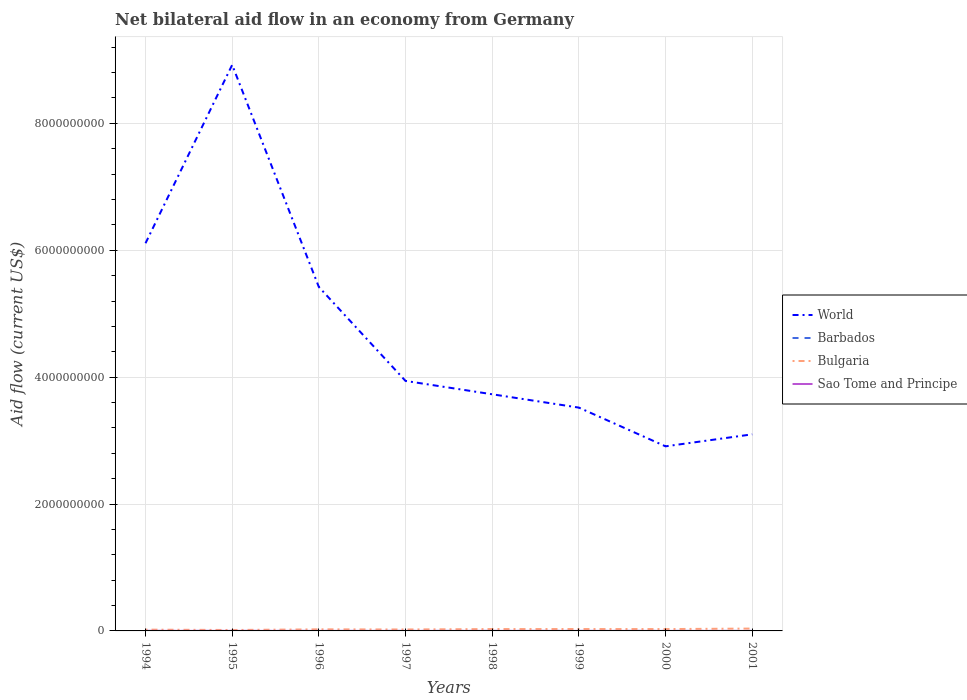How many different coloured lines are there?
Make the answer very short. 4. Is the number of lines equal to the number of legend labels?
Ensure brevity in your answer.  Yes. What is the total net bilateral aid flow in Bulgaria in the graph?
Your response must be concise. -1.44e+07. What is the difference between the highest and the second highest net bilateral aid flow in Sao Tome and Principe?
Ensure brevity in your answer.  8.80e+05. What is the difference between the highest and the lowest net bilateral aid flow in World?
Make the answer very short. 3. Is the net bilateral aid flow in Sao Tome and Principe strictly greater than the net bilateral aid flow in Barbados over the years?
Offer a terse response. No. What is the difference between two consecutive major ticks on the Y-axis?
Your response must be concise. 2.00e+09. Are the values on the major ticks of Y-axis written in scientific E-notation?
Make the answer very short. No. How many legend labels are there?
Offer a very short reply. 4. How are the legend labels stacked?
Offer a very short reply. Vertical. What is the title of the graph?
Make the answer very short. Net bilateral aid flow in an economy from Germany. Does "China" appear as one of the legend labels in the graph?
Your answer should be compact. No. What is the Aid flow (current US$) in World in 1994?
Your answer should be compact. 6.11e+09. What is the Aid flow (current US$) in Bulgaria in 1994?
Your answer should be compact. 2.02e+07. What is the Aid flow (current US$) of Sao Tome and Principe in 1994?
Offer a very short reply. 9.20e+05. What is the Aid flow (current US$) of World in 1995?
Keep it short and to the point. 8.92e+09. What is the Aid flow (current US$) in Barbados in 1995?
Ensure brevity in your answer.  3.00e+04. What is the Aid flow (current US$) of Bulgaria in 1995?
Give a very brief answer. 1.47e+07. What is the Aid flow (current US$) of Sao Tome and Principe in 1995?
Offer a terse response. 8.30e+05. What is the Aid flow (current US$) of World in 1996?
Your response must be concise. 5.42e+09. What is the Aid flow (current US$) of Bulgaria in 1996?
Keep it short and to the point. 2.50e+07. What is the Aid flow (current US$) in Sao Tome and Principe in 1996?
Ensure brevity in your answer.  5.80e+05. What is the Aid flow (current US$) of World in 1997?
Offer a very short reply. 3.94e+09. What is the Aid flow (current US$) in Barbados in 1997?
Offer a very short reply. 5.00e+04. What is the Aid flow (current US$) in Bulgaria in 1997?
Offer a very short reply. 2.27e+07. What is the Aid flow (current US$) of Sao Tome and Principe in 1997?
Offer a terse response. 3.00e+05. What is the Aid flow (current US$) in World in 1998?
Keep it short and to the point. 3.73e+09. What is the Aid flow (current US$) of Barbados in 1998?
Give a very brief answer. 7.00e+04. What is the Aid flow (current US$) of Bulgaria in 1998?
Ensure brevity in your answer.  2.92e+07. What is the Aid flow (current US$) in World in 1999?
Provide a succinct answer. 3.52e+09. What is the Aid flow (current US$) in Barbados in 1999?
Make the answer very short. 1.20e+05. What is the Aid flow (current US$) in Bulgaria in 1999?
Provide a short and direct response. 2.96e+07. What is the Aid flow (current US$) in World in 2000?
Offer a terse response. 2.91e+09. What is the Aid flow (current US$) of Barbados in 2000?
Provide a short and direct response. 4.00e+04. What is the Aid flow (current US$) of Bulgaria in 2000?
Make the answer very short. 2.91e+07. What is the Aid flow (current US$) in Sao Tome and Principe in 2000?
Keep it short and to the point. 1.60e+05. What is the Aid flow (current US$) in World in 2001?
Provide a short and direct response. 3.10e+09. What is the Aid flow (current US$) of Bulgaria in 2001?
Keep it short and to the point. 3.71e+07. Across all years, what is the maximum Aid flow (current US$) in World?
Provide a succinct answer. 8.92e+09. Across all years, what is the maximum Aid flow (current US$) of Barbados?
Give a very brief answer. 1.20e+05. Across all years, what is the maximum Aid flow (current US$) in Bulgaria?
Your answer should be compact. 3.71e+07. Across all years, what is the maximum Aid flow (current US$) of Sao Tome and Principe?
Offer a terse response. 9.20e+05. Across all years, what is the minimum Aid flow (current US$) in World?
Offer a very short reply. 2.91e+09. Across all years, what is the minimum Aid flow (current US$) in Barbados?
Offer a terse response. 3.00e+04. Across all years, what is the minimum Aid flow (current US$) of Bulgaria?
Offer a very short reply. 1.47e+07. Across all years, what is the minimum Aid flow (current US$) in Sao Tome and Principe?
Offer a terse response. 4.00e+04. What is the total Aid flow (current US$) in World in the graph?
Provide a short and direct response. 3.77e+1. What is the total Aid flow (current US$) of Barbados in the graph?
Your answer should be very brief. 4.60e+05. What is the total Aid flow (current US$) of Bulgaria in the graph?
Your answer should be compact. 2.08e+08. What is the total Aid flow (current US$) in Sao Tome and Principe in the graph?
Offer a terse response. 3.50e+06. What is the difference between the Aid flow (current US$) of World in 1994 and that in 1995?
Provide a short and direct response. -2.81e+09. What is the difference between the Aid flow (current US$) in Bulgaria in 1994 and that in 1995?
Provide a short and direct response. 5.55e+06. What is the difference between the Aid flow (current US$) of Sao Tome and Principe in 1994 and that in 1995?
Offer a terse response. 9.00e+04. What is the difference between the Aid flow (current US$) of World in 1994 and that in 1996?
Give a very brief answer. 6.89e+08. What is the difference between the Aid flow (current US$) of Barbados in 1994 and that in 1996?
Your answer should be very brief. 0. What is the difference between the Aid flow (current US$) in Bulgaria in 1994 and that in 1996?
Keep it short and to the point. -4.76e+06. What is the difference between the Aid flow (current US$) in World in 1994 and that in 1997?
Ensure brevity in your answer.  2.17e+09. What is the difference between the Aid flow (current US$) in Bulgaria in 1994 and that in 1997?
Your answer should be very brief. -2.50e+06. What is the difference between the Aid flow (current US$) in Sao Tome and Principe in 1994 and that in 1997?
Ensure brevity in your answer.  6.20e+05. What is the difference between the Aid flow (current US$) of World in 1994 and that in 1998?
Keep it short and to the point. 2.38e+09. What is the difference between the Aid flow (current US$) in Barbados in 1994 and that in 1998?
Your answer should be very brief. -4.00e+04. What is the difference between the Aid flow (current US$) in Bulgaria in 1994 and that in 1998?
Ensure brevity in your answer.  -9.01e+06. What is the difference between the Aid flow (current US$) of Sao Tome and Principe in 1994 and that in 1998?
Provide a succinct answer. 4.90e+05. What is the difference between the Aid flow (current US$) of World in 1994 and that in 1999?
Provide a succinct answer. 2.59e+09. What is the difference between the Aid flow (current US$) of Barbados in 1994 and that in 1999?
Offer a terse response. -9.00e+04. What is the difference between the Aid flow (current US$) in Bulgaria in 1994 and that in 1999?
Your answer should be very brief. -9.35e+06. What is the difference between the Aid flow (current US$) of Sao Tome and Principe in 1994 and that in 1999?
Provide a succinct answer. 6.80e+05. What is the difference between the Aid flow (current US$) of World in 1994 and that in 2000?
Your answer should be very brief. 3.20e+09. What is the difference between the Aid flow (current US$) of Barbados in 1994 and that in 2000?
Offer a very short reply. -10000. What is the difference between the Aid flow (current US$) in Bulgaria in 1994 and that in 2000?
Make the answer very short. -8.87e+06. What is the difference between the Aid flow (current US$) of Sao Tome and Principe in 1994 and that in 2000?
Your answer should be compact. 7.60e+05. What is the difference between the Aid flow (current US$) of World in 1994 and that in 2001?
Your answer should be very brief. 3.01e+09. What is the difference between the Aid flow (current US$) of Bulgaria in 1994 and that in 2001?
Ensure brevity in your answer.  -1.69e+07. What is the difference between the Aid flow (current US$) in Sao Tome and Principe in 1994 and that in 2001?
Your answer should be compact. 8.80e+05. What is the difference between the Aid flow (current US$) of World in 1995 and that in 1996?
Keep it short and to the point. 3.50e+09. What is the difference between the Aid flow (current US$) of Bulgaria in 1995 and that in 1996?
Provide a succinct answer. -1.03e+07. What is the difference between the Aid flow (current US$) of Sao Tome and Principe in 1995 and that in 1996?
Make the answer very short. 2.50e+05. What is the difference between the Aid flow (current US$) in World in 1995 and that in 1997?
Your answer should be very brief. 4.98e+09. What is the difference between the Aid flow (current US$) of Bulgaria in 1995 and that in 1997?
Keep it short and to the point. -8.05e+06. What is the difference between the Aid flow (current US$) of Sao Tome and Principe in 1995 and that in 1997?
Give a very brief answer. 5.30e+05. What is the difference between the Aid flow (current US$) in World in 1995 and that in 1998?
Your answer should be very brief. 5.19e+09. What is the difference between the Aid flow (current US$) in Barbados in 1995 and that in 1998?
Your answer should be compact. -4.00e+04. What is the difference between the Aid flow (current US$) in Bulgaria in 1995 and that in 1998?
Make the answer very short. -1.46e+07. What is the difference between the Aid flow (current US$) of World in 1995 and that in 1999?
Give a very brief answer. 5.40e+09. What is the difference between the Aid flow (current US$) in Barbados in 1995 and that in 1999?
Offer a very short reply. -9.00e+04. What is the difference between the Aid flow (current US$) in Bulgaria in 1995 and that in 1999?
Your response must be concise. -1.49e+07. What is the difference between the Aid flow (current US$) of Sao Tome and Principe in 1995 and that in 1999?
Ensure brevity in your answer.  5.90e+05. What is the difference between the Aid flow (current US$) in World in 1995 and that in 2000?
Your answer should be very brief. 6.01e+09. What is the difference between the Aid flow (current US$) of Bulgaria in 1995 and that in 2000?
Offer a very short reply. -1.44e+07. What is the difference between the Aid flow (current US$) in Sao Tome and Principe in 1995 and that in 2000?
Give a very brief answer. 6.70e+05. What is the difference between the Aid flow (current US$) in World in 1995 and that in 2001?
Your answer should be very brief. 5.82e+09. What is the difference between the Aid flow (current US$) of Bulgaria in 1995 and that in 2001?
Your answer should be compact. -2.24e+07. What is the difference between the Aid flow (current US$) in Sao Tome and Principe in 1995 and that in 2001?
Your answer should be very brief. 7.90e+05. What is the difference between the Aid flow (current US$) in World in 1996 and that in 1997?
Provide a succinct answer. 1.48e+09. What is the difference between the Aid flow (current US$) of Barbados in 1996 and that in 1997?
Your answer should be compact. -2.00e+04. What is the difference between the Aid flow (current US$) in Bulgaria in 1996 and that in 1997?
Offer a terse response. 2.26e+06. What is the difference between the Aid flow (current US$) of Sao Tome and Principe in 1996 and that in 1997?
Provide a succinct answer. 2.80e+05. What is the difference between the Aid flow (current US$) in World in 1996 and that in 1998?
Make the answer very short. 1.69e+09. What is the difference between the Aid flow (current US$) of Bulgaria in 1996 and that in 1998?
Your answer should be compact. -4.25e+06. What is the difference between the Aid flow (current US$) in World in 1996 and that in 1999?
Your response must be concise. 1.90e+09. What is the difference between the Aid flow (current US$) of Barbados in 1996 and that in 1999?
Your answer should be very brief. -9.00e+04. What is the difference between the Aid flow (current US$) of Bulgaria in 1996 and that in 1999?
Make the answer very short. -4.59e+06. What is the difference between the Aid flow (current US$) in World in 1996 and that in 2000?
Provide a succinct answer. 2.51e+09. What is the difference between the Aid flow (current US$) of Bulgaria in 1996 and that in 2000?
Provide a short and direct response. -4.11e+06. What is the difference between the Aid flow (current US$) of Sao Tome and Principe in 1996 and that in 2000?
Provide a succinct answer. 4.20e+05. What is the difference between the Aid flow (current US$) of World in 1996 and that in 2001?
Give a very brief answer. 2.32e+09. What is the difference between the Aid flow (current US$) of Barbados in 1996 and that in 2001?
Ensure brevity in your answer.  -6.00e+04. What is the difference between the Aid flow (current US$) of Bulgaria in 1996 and that in 2001?
Offer a terse response. -1.21e+07. What is the difference between the Aid flow (current US$) in Sao Tome and Principe in 1996 and that in 2001?
Make the answer very short. 5.40e+05. What is the difference between the Aid flow (current US$) of World in 1997 and that in 1998?
Your answer should be compact. 2.10e+08. What is the difference between the Aid flow (current US$) of Bulgaria in 1997 and that in 1998?
Offer a terse response. -6.51e+06. What is the difference between the Aid flow (current US$) of Sao Tome and Principe in 1997 and that in 1998?
Provide a succinct answer. -1.30e+05. What is the difference between the Aid flow (current US$) of World in 1997 and that in 1999?
Your answer should be compact. 4.20e+08. What is the difference between the Aid flow (current US$) in Barbados in 1997 and that in 1999?
Your answer should be compact. -7.00e+04. What is the difference between the Aid flow (current US$) of Bulgaria in 1997 and that in 1999?
Provide a short and direct response. -6.85e+06. What is the difference between the Aid flow (current US$) of World in 1997 and that in 2000?
Give a very brief answer. 1.03e+09. What is the difference between the Aid flow (current US$) in Bulgaria in 1997 and that in 2000?
Ensure brevity in your answer.  -6.37e+06. What is the difference between the Aid flow (current US$) in Sao Tome and Principe in 1997 and that in 2000?
Keep it short and to the point. 1.40e+05. What is the difference between the Aid flow (current US$) in World in 1997 and that in 2001?
Keep it short and to the point. 8.42e+08. What is the difference between the Aid flow (current US$) in Barbados in 1997 and that in 2001?
Keep it short and to the point. -4.00e+04. What is the difference between the Aid flow (current US$) of Bulgaria in 1997 and that in 2001?
Provide a short and direct response. -1.44e+07. What is the difference between the Aid flow (current US$) of World in 1998 and that in 1999?
Provide a short and direct response. 2.10e+08. What is the difference between the Aid flow (current US$) in Sao Tome and Principe in 1998 and that in 1999?
Ensure brevity in your answer.  1.90e+05. What is the difference between the Aid flow (current US$) in World in 1998 and that in 2000?
Your answer should be compact. 8.20e+08. What is the difference between the Aid flow (current US$) of Barbados in 1998 and that in 2000?
Offer a very short reply. 3.00e+04. What is the difference between the Aid flow (current US$) in World in 1998 and that in 2001?
Provide a short and direct response. 6.31e+08. What is the difference between the Aid flow (current US$) of Bulgaria in 1998 and that in 2001?
Your answer should be compact. -7.87e+06. What is the difference between the Aid flow (current US$) of Sao Tome and Principe in 1998 and that in 2001?
Offer a very short reply. 3.90e+05. What is the difference between the Aid flow (current US$) of World in 1999 and that in 2000?
Offer a terse response. 6.10e+08. What is the difference between the Aid flow (current US$) of Bulgaria in 1999 and that in 2000?
Ensure brevity in your answer.  4.80e+05. What is the difference between the Aid flow (current US$) in Sao Tome and Principe in 1999 and that in 2000?
Offer a very short reply. 8.00e+04. What is the difference between the Aid flow (current US$) of World in 1999 and that in 2001?
Your answer should be compact. 4.21e+08. What is the difference between the Aid flow (current US$) in Bulgaria in 1999 and that in 2001?
Ensure brevity in your answer.  -7.53e+06. What is the difference between the Aid flow (current US$) of Sao Tome and Principe in 1999 and that in 2001?
Your answer should be compact. 2.00e+05. What is the difference between the Aid flow (current US$) in World in 2000 and that in 2001?
Provide a short and direct response. -1.89e+08. What is the difference between the Aid flow (current US$) of Barbados in 2000 and that in 2001?
Give a very brief answer. -5.00e+04. What is the difference between the Aid flow (current US$) of Bulgaria in 2000 and that in 2001?
Your answer should be compact. -8.01e+06. What is the difference between the Aid flow (current US$) in World in 1994 and the Aid flow (current US$) in Barbados in 1995?
Give a very brief answer. 6.11e+09. What is the difference between the Aid flow (current US$) in World in 1994 and the Aid flow (current US$) in Bulgaria in 1995?
Ensure brevity in your answer.  6.10e+09. What is the difference between the Aid flow (current US$) of World in 1994 and the Aid flow (current US$) of Sao Tome and Principe in 1995?
Your answer should be very brief. 6.11e+09. What is the difference between the Aid flow (current US$) of Barbados in 1994 and the Aid flow (current US$) of Bulgaria in 1995?
Offer a very short reply. -1.46e+07. What is the difference between the Aid flow (current US$) of Barbados in 1994 and the Aid flow (current US$) of Sao Tome and Principe in 1995?
Ensure brevity in your answer.  -8.00e+05. What is the difference between the Aid flow (current US$) in Bulgaria in 1994 and the Aid flow (current US$) in Sao Tome and Principe in 1995?
Make the answer very short. 1.94e+07. What is the difference between the Aid flow (current US$) of World in 1994 and the Aid flow (current US$) of Barbados in 1996?
Provide a succinct answer. 6.11e+09. What is the difference between the Aid flow (current US$) in World in 1994 and the Aid flow (current US$) in Bulgaria in 1996?
Make the answer very short. 6.09e+09. What is the difference between the Aid flow (current US$) in World in 1994 and the Aid flow (current US$) in Sao Tome and Principe in 1996?
Make the answer very short. 6.11e+09. What is the difference between the Aid flow (current US$) of Barbados in 1994 and the Aid flow (current US$) of Bulgaria in 1996?
Your answer should be compact. -2.49e+07. What is the difference between the Aid flow (current US$) of Barbados in 1994 and the Aid flow (current US$) of Sao Tome and Principe in 1996?
Your answer should be compact. -5.50e+05. What is the difference between the Aid flow (current US$) of Bulgaria in 1994 and the Aid flow (current US$) of Sao Tome and Principe in 1996?
Your answer should be very brief. 1.96e+07. What is the difference between the Aid flow (current US$) in World in 1994 and the Aid flow (current US$) in Barbados in 1997?
Your answer should be very brief. 6.11e+09. What is the difference between the Aid flow (current US$) in World in 1994 and the Aid flow (current US$) in Bulgaria in 1997?
Provide a succinct answer. 6.09e+09. What is the difference between the Aid flow (current US$) in World in 1994 and the Aid flow (current US$) in Sao Tome and Principe in 1997?
Make the answer very short. 6.11e+09. What is the difference between the Aid flow (current US$) of Barbados in 1994 and the Aid flow (current US$) of Bulgaria in 1997?
Keep it short and to the point. -2.27e+07. What is the difference between the Aid flow (current US$) of Bulgaria in 1994 and the Aid flow (current US$) of Sao Tome and Principe in 1997?
Keep it short and to the point. 1.99e+07. What is the difference between the Aid flow (current US$) of World in 1994 and the Aid flow (current US$) of Barbados in 1998?
Provide a short and direct response. 6.11e+09. What is the difference between the Aid flow (current US$) in World in 1994 and the Aid flow (current US$) in Bulgaria in 1998?
Your answer should be very brief. 6.08e+09. What is the difference between the Aid flow (current US$) in World in 1994 and the Aid flow (current US$) in Sao Tome and Principe in 1998?
Offer a terse response. 6.11e+09. What is the difference between the Aid flow (current US$) in Barbados in 1994 and the Aid flow (current US$) in Bulgaria in 1998?
Keep it short and to the point. -2.92e+07. What is the difference between the Aid flow (current US$) in Barbados in 1994 and the Aid flow (current US$) in Sao Tome and Principe in 1998?
Your answer should be compact. -4.00e+05. What is the difference between the Aid flow (current US$) in Bulgaria in 1994 and the Aid flow (current US$) in Sao Tome and Principe in 1998?
Provide a succinct answer. 1.98e+07. What is the difference between the Aid flow (current US$) in World in 1994 and the Aid flow (current US$) in Barbados in 1999?
Keep it short and to the point. 6.11e+09. What is the difference between the Aid flow (current US$) in World in 1994 and the Aid flow (current US$) in Bulgaria in 1999?
Your answer should be very brief. 6.08e+09. What is the difference between the Aid flow (current US$) in World in 1994 and the Aid flow (current US$) in Sao Tome and Principe in 1999?
Your answer should be compact. 6.11e+09. What is the difference between the Aid flow (current US$) in Barbados in 1994 and the Aid flow (current US$) in Bulgaria in 1999?
Your answer should be compact. -2.95e+07. What is the difference between the Aid flow (current US$) of Bulgaria in 1994 and the Aid flow (current US$) of Sao Tome and Principe in 1999?
Ensure brevity in your answer.  2.00e+07. What is the difference between the Aid flow (current US$) in World in 1994 and the Aid flow (current US$) in Barbados in 2000?
Keep it short and to the point. 6.11e+09. What is the difference between the Aid flow (current US$) of World in 1994 and the Aid flow (current US$) of Bulgaria in 2000?
Provide a short and direct response. 6.08e+09. What is the difference between the Aid flow (current US$) in World in 1994 and the Aid flow (current US$) in Sao Tome and Principe in 2000?
Your answer should be compact. 6.11e+09. What is the difference between the Aid flow (current US$) in Barbados in 1994 and the Aid flow (current US$) in Bulgaria in 2000?
Your answer should be compact. -2.90e+07. What is the difference between the Aid flow (current US$) of Barbados in 1994 and the Aid flow (current US$) of Sao Tome and Principe in 2000?
Offer a terse response. -1.30e+05. What is the difference between the Aid flow (current US$) of Bulgaria in 1994 and the Aid flow (current US$) of Sao Tome and Principe in 2000?
Provide a succinct answer. 2.00e+07. What is the difference between the Aid flow (current US$) of World in 1994 and the Aid flow (current US$) of Barbados in 2001?
Your response must be concise. 6.11e+09. What is the difference between the Aid flow (current US$) of World in 1994 and the Aid flow (current US$) of Bulgaria in 2001?
Ensure brevity in your answer.  6.07e+09. What is the difference between the Aid flow (current US$) of World in 1994 and the Aid flow (current US$) of Sao Tome and Principe in 2001?
Your answer should be very brief. 6.11e+09. What is the difference between the Aid flow (current US$) of Barbados in 1994 and the Aid flow (current US$) of Bulgaria in 2001?
Ensure brevity in your answer.  -3.71e+07. What is the difference between the Aid flow (current US$) of Barbados in 1994 and the Aid flow (current US$) of Sao Tome and Principe in 2001?
Your answer should be very brief. -10000. What is the difference between the Aid flow (current US$) of Bulgaria in 1994 and the Aid flow (current US$) of Sao Tome and Principe in 2001?
Your answer should be compact. 2.02e+07. What is the difference between the Aid flow (current US$) of World in 1995 and the Aid flow (current US$) of Barbados in 1996?
Offer a terse response. 8.92e+09. What is the difference between the Aid flow (current US$) of World in 1995 and the Aid flow (current US$) of Bulgaria in 1996?
Your response must be concise. 8.90e+09. What is the difference between the Aid flow (current US$) of World in 1995 and the Aid flow (current US$) of Sao Tome and Principe in 1996?
Keep it short and to the point. 8.92e+09. What is the difference between the Aid flow (current US$) of Barbados in 1995 and the Aid flow (current US$) of Bulgaria in 1996?
Your response must be concise. -2.49e+07. What is the difference between the Aid flow (current US$) of Barbados in 1995 and the Aid flow (current US$) of Sao Tome and Principe in 1996?
Keep it short and to the point. -5.50e+05. What is the difference between the Aid flow (current US$) of Bulgaria in 1995 and the Aid flow (current US$) of Sao Tome and Principe in 1996?
Your response must be concise. 1.41e+07. What is the difference between the Aid flow (current US$) in World in 1995 and the Aid flow (current US$) in Barbados in 1997?
Provide a succinct answer. 8.92e+09. What is the difference between the Aid flow (current US$) of World in 1995 and the Aid flow (current US$) of Bulgaria in 1997?
Keep it short and to the point. 8.90e+09. What is the difference between the Aid flow (current US$) of World in 1995 and the Aid flow (current US$) of Sao Tome and Principe in 1997?
Your answer should be compact. 8.92e+09. What is the difference between the Aid flow (current US$) of Barbados in 1995 and the Aid flow (current US$) of Bulgaria in 1997?
Offer a terse response. -2.27e+07. What is the difference between the Aid flow (current US$) in Bulgaria in 1995 and the Aid flow (current US$) in Sao Tome and Principe in 1997?
Offer a terse response. 1.44e+07. What is the difference between the Aid flow (current US$) in World in 1995 and the Aid flow (current US$) in Barbados in 1998?
Make the answer very short. 8.92e+09. What is the difference between the Aid flow (current US$) of World in 1995 and the Aid flow (current US$) of Bulgaria in 1998?
Provide a short and direct response. 8.89e+09. What is the difference between the Aid flow (current US$) in World in 1995 and the Aid flow (current US$) in Sao Tome and Principe in 1998?
Give a very brief answer. 8.92e+09. What is the difference between the Aid flow (current US$) in Barbados in 1995 and the Aid flow (current US$) in Bulgaria in 1998?
Your answer should be compact. -2.92e+07. What is the difference between the Aid flow (current US$) in Barbados in 1995 and the Aid flow (current US$) in Sao Tome and Principe in 1998?
Offer a very short reply. -4.00e+05. What is the difference between the Aid flow (current US$) of Bulgaria in 1995 and the Aid flow (current US$) of Sao Tome and Principe in 1998?
Provide a succinct answer. 1.42e+07. What is the difference between the Aid flow (current US$) of World in 1995 and the Aid flow (current US$) of Barbados in 1999?
Provide a succinct answer. 8.92e+09. What is the difference between the Aid flow (current US$) of World in 1995 and the Aid flow (current US$) of Bulgaria in 1999?
Provide a succinct answer. 8.89e+09. What is the difference between the Aid flow (current US$) of World in 1995 and the Aid flow (current US$) of Sao Tome and Principe in 1999?
Make the answer very short. 8.92e+09. What is the difference between the Aid flow (current US$) of Barbados in 1995 and the Aid flow (current US$) of Bulgaria in 1999?
Your answer should be very brief. -2.95e+07. What is the difference between the Aid flow (current US$) in Barbados in 1995 and the Aid flow (current US$) in Sao Tome and Principe in 1999?
Keep it short and to the point. -2.10e+05. What is the difference between the Aid flow (current US$) of Bulgaria in 1995 and the Aid flow (current US$) of Sao Tome and Principe in 1999?
Your response must be concise. 1.44e+07. What is the difference between the Aid flow (current US$) in World in 1995 and the Aid flow (current US$) in Barbados in 2000?
Give a very brief answer. 8.92e+09. What is the difference between the Aid flow (current US$) in World in 1995 and the Aid flow (current US$) in Bulgaria in 2000?
Provide a succinct answer. 8.89e+09. What is the difference between the Aid flow (current US$) in World in 1995 and the Aid flow (current US$) in Sao Tome and Principe in 2000?
Provide a short and direct response. 8.92e+09. What is the difference between the Aid flow (current US$) of Barbados in 1995 and the Aid flow (current US$) of Bulgaria in 2000?
Offer a very short reply. -2.90e+07. What is the difference between the Aid flow (current US$) in Bulgaria in 1995 and the Aid flow (current US$) in Sao Tome and Principe in 2000?
Make the answer very short. 1.45e+07. What is the difference between the Aid flow (current US$) of World in 1995 and the Aid flow (current US$) of Barbados in 2001?
Offer a very short reply. 8.92e+09. What is the difference between the Aid flow (current US$) of World in 1995 and the Aid flow (current US$) of Bulgaria in 2001?
Your answer should be compact. 8.88e+09. What is the difference between the Aid flow (current US$) of World in 1995 and the Aid flow (current US$) of Sao Tome and Principe in 2001?
Ensure brevity in your answer.  8.92e+09. What is the difference between the Aid flow (current US$) of Barbados in 1995 and the Aid flow (current US$) of Bulgaria in 2001?
Your answer should be compact. -3.71e+07. What is the difference between the Aid flow (current US$) of Bulgaria in 1995 and the Aid flow (current US$) of Sao Tome and Principe in 2001?
Your response must be concise. 1.46e+07. What is the difference between the Aid flow (current US$) of World in 1996 and the Aid flow (current US$) of Barbados in 1997?
Your answer should be compact. 5.42e+09. What is the difference between the Aid flow (current US$) in World in 1996 and the Aid flow (current US$) in Bulgaria in 1997?
Ensure brevity in your answer.  5.40e+09. What is the difference between the Aid flow (current US$) in World in 1996 and the Aid flow (current US$) in Sao Tome and Principe in 1997?
Your answer should be compact. 5.42e+09. What is the difference between the Aid flow (current US$) in Barbados in 1996 and the Aid flow (current US$) in Bulgaria in 1997?
Give a very brief answer. -2.27e+07. What is the difference between the Aid flow (current US$) of Bulgaria in 1996 and the Aid flow (current US$) of Sao Tome and Principe in 1997?
Offer a very short reply. 2.47e+07. What is the difference between the Aid flow (current US$) in World in 1996 and the Aid flow (current US$) in Barbados in 1998?
Your answer should be very brief. 5.42e+09. What is the difference between the Aid flow (current US$) of World in 1996 and the Aid flow (current US$) of Bulgaria in 1998?
Give a very brief answer. 5.39e+09. What is the difference between the Aid flow (current US$) of World in 1996 and the Aid flow (current US$) of Sao Tome and Principe in 1998?
Keep it short and to the point. 5.42e+09. What is the difference between the Aid flow (current US$) in Barbados in 1996 and the Aid flow (current US$) in Bulgaria in 1998?
Your answer should be compact. -2.92e+07. What is the difference between the Aid flow (current US$) of Barbados in 1996 and the Aid flow (current US$) of Sao Tome and Principe in 1998?
Offer a very short reply. -4.00e+05. What is the difference between the Aid flow (current US$) in Bulgaria in 1996 and the Aid flow (current US$) in Sao Tome and Principe in 1998?
Keep it short and to the point. 2.45e+07. What is the difference between the Aid flow (current US$) in World in 1996 and the Aid flow (current US$) in Barbados in 1999?
Keep it short and to the point. 5.42e+09. What is the difference between the Aid flow (current US$) of World in 1996 and the Aid flow (current US$) of Bulgaria in 1999?
Ensure brevity in your answer.  5.39e+09. What is the difference between the Aid flow (current US$) of World in 1996 and the Aid flow (current US$) of Sao Tome and Principe in 1999?
Ensure brevity in your answer.  5.42e+09. What is the difference between the Aid flow (current US$) of Barbados in 1996 and the Aid flow (current US$) of Bulgaria in 1999?
Ensure brevity in your answer.  -2.95e+07. What is the difference between the Aid flow (current US$) of Bulgaria in 1996 and the Aid flow (current US$) of Sao Tome and Principe in 1999?
Keep it short and to the point. 2.47e+07. What is the difference between the Aid flow (current US$) in World in 1996 and the Aid flow (current US$) in Barbados in 2000?
Your answer should be very brief. 5.42e+09. What is the difference between the Aid flow (current US$) in World in 1996 and the Aid flow (current US$) in Bulgaria in 2000?
Keep it short and to the point. 5.39e+09. What is the difference between the Aid flow (current US$) in World in 1996 and the Aid flow (current US$) in Sao Tome and Principe in 2000?
Your answer should be very brief. 5.42e+09. What is the difference between the Aid flow (current US$) of Barbados in 1996 and the Aid flow (current US$) of Bulgaria in 2000?
Your response must be concise. -2.90e+07. What is the difference between the Aid flow (current US$) of Barbados in 1996 and the Aid flow (current US$) of Sao Tome and Principe in 2000?
Ensure brevity in your answer.  -1.30e+05. What is the difference between the Aid flow (current US$) in Bulgaria in 1996 and the Aid flow (current US$) in Sao Tome and Principe in 2000?
Your answer should be compact. 2.48e+07. What is the difference between the Aid flow (current US$) in World in 1996 and the Aid flow (current US$) in Barbados in 2001?
Offer a terse response. 5.42e+09. What is the difference between the Aid flow (current US$) in World in 1996 and the Aid flow (current US$) in Bulgaria in 2001?
Offer a terse response. 5.38e+09. What is the difference between the Aid flow (current US$) of World in 1996 and the Aid flow (current US$) of Sao Tome and Principe in 2001?
Ensure brevity in your answer.  5.42e+09. What is the difference between the Aid flow (current US$) of Barbados in 1996 and the Aid flow (current US$) of Bulgaria in 2001?
Provide a succinct answer. -3.71e+07. What is the difference between the Aid flow (current US$) in Barbados in 1996 and the Aid flow (current US$) in Sao Tome and Principe in 2001?
Give a very brief answer. -10000. What is the difference between the Aid flow (current US$) of Bulgaria in 1996 and the Aid flow (current US$) of Sao Tome and Principe in 2001?
Your response must be concise. 2.49e+07. What is the difference between the Aid flow (current US$) in World in 1997 and the Aid flow (current US$) in Barbados in 1998?
Provide a short and direct response. 3.94e+09. What is the difference between the Aid flow (current US$) of World in 1997 and the Aid flow (current US$) of Bulgaria in 1998?
Ensure brevity in your answer.  3.91e+09. What is the difference between the Aid flow (current US$) in World in 1997 and the Aid flow (current US$) in Sao Tome and Principe in 1998?
Make the answer very short. 3.94e+09. What is the difference between the Aid flow (current US$) of Barbados in 1997 and the Aid flow (current US$) of Bulgaria in 1998?
Your response must be concise. -2.92e+07. What is the difference between the Aid flow (current US$) in Barbados in 1997 and the Aid flow (current US$) in Sao Tome and Principe in 1998?
Your answer should be very brief. -3.80e+05. What is the difference between the Aid flow (current US$) of Bulgaria in 1997 and the Aid flow (current US$) of Sao Tome and Principe in 1998?
Your answer should be very brief. 2.23e+07. What is the difference between the Aid flow (current US$) of World in 1997 and the Aid flow (current US$) of Barbados in 1999?
Your response must be concise. 3.94e+09. What is the difference between the Aid flow (current US$) in World in 1997 and the Aid flow (current US$) in Bulgaria in 1999?
Keep it short and to the point. 3.91e+09. What is the difference between the Aid flow (current US$) in World in 1997 and the Aid flow (current US$) in Sao Tome and Principe in 1999?
Offer a terse response. 3.94e+09. What is the difference between the Aid flow (current US$) in Barbados in 1997 and the Aid flow (current US$) in Bulgaria in 1999?
Your answer should be compact. -2.95e+07. What is the difference between the Aid flow (current US$) of Barbados in 1997 and the Aid flow (current US$) of Sao Tome and Principe in 1999?
Provide a short and direct response. -1.90e+05. What is the difference between the Aid flow (current US$) of Bulgaria in 1997 and the Aid flow (current US$) of Sao Tome and Principe in 1999?
Provide a succinct answer. 2.25e+07. What is the difference between the Aid flow (current US$) of World in 1997 and the Aid flow (current US$) of Barbados in 2000?
Make the answer very short. 3.94e+09. What is the difference between the Aid flow (current US$) in World in 1997 and the Aid flow (current US$) in Bulgaria in 2000?
Give a very brief answer. 3.91e+09. What is the difference between the Aid flow (current US$) of World in 1997 and the Aid flow (current US$) of Sao Tome and Principe in 2000?
Provide a short and direct response. 3.94e+09. What is the difference between the Aid flow (current US$) in Barbados in 1997 and the Aid flow (current US$) in Bulgaria in 2000?
Offer a terse response. -2.90e+07. What is the difference between the Aid flow (current US$) in Barbados in 1997 and the Aid flow (current US$) in Sao Tome and Principe in 2000?
Keep it short and to the point. -1.10e+05. What is the difference between the Aid flow (current US$) in Bulgaria in 1997 and the Aid flow (current US$) in Sao Tome and Principe in 2000?
Provide a succinct answer. 2.26e+07. What is the difference between the Aid flow (current US$) in World in 1997 and the Aid flow (current US$) in Barbados in 2001?
Provide a succinct answer. 3.94e+09. What is the difference between the Aid flow (current US$) in World in 1997 and the Aid flow (current US$) in Bulgaria in 2001?
Ensure brevity in your answer.  3.90e+09. What is the difference between the Aid flow (current US$) in World in 1997 and the Aid flow (current US$) in Sao Tome and Principe in 2001?
Provide a succinct answer. 3.94e+09. What is the difference between the Aid flow (current US$) in Barbados in 1997 and the Aid flow (current US$) in Bulgaria in 2001?
Provide a short and direct response. -3.70e+07. What is the difference between the Aid flow (current US$) in Barbados in 1997 and the Aid flow (current US$) in Sao Tome and Principe in 2001?
Offer a terse response. 10000. What is the difference between the Aid flow (current US$) in Bulgaria in 1997 and the Aid flow (current US$) in Sao Tome and Principe in 2001?
Offer a very short reply. 2.27e+07. What is the difference between the Aid flow (current US$) in World in 1998 and the Aid flow (current US$) in Barbados in 1999?
Offer a terse response. 3.73e+09. What is the difference between the Aid flow (current US$) in World in 1998 and the Aid flow (current US$) in Bulgaria in 1999?
Your answer should be very brief. 3.70e+09. What is the difference between the Aid flow (current US$) in World in 1998 and the Aid flow (current US$) in Sao Tome and Principe in 1999?
Your answer should be compact. 3.73e+09. What is the difference between the Aid flow (current US$) in Barbados in 1998 and the Aid flow (current US$) in Bulgaria in 1999?
Ensure brevity in your answer.  -2.95e+07. What is the difference between the Aid flow (current US$) of Barbados in 1998 and the Aid flow (current US$) of Sao Tome and Principe in 1999?
Offer a very short reply. -1.70e+05. What is the difference between the Aid flow (current US$) of Bulgaria in 1998 and the Aid flow (current US$) of Sao Tome and Principe in 1999?
Your answer should be very brief. 2.90e+07. What is the difference between the Aid flow (current US$) in World in 1998 and the Aid flow (current US$) in Barbados in 2000?
Your response must be concise. 3.73e+09. What is the difference between the Aid flow (current US$) of World in 1998 and the Aid flow (current US$) of Bulgaria in 2000?
Make the answer very short. 3.70e+09. What is the difference between the Aid flow (current US$) in World in 1998 and the Aid flow (current US$) in Sao Tome and Principe in 2000?
Ensure brevity in your answer.  3.73e+09. What is the difference between the Aid flow (current US$) of Barbados in 1998 and the Aid flow (current US$) of Bulgaria in 2000?
Offer a very short reply. -2.90e+07. What is the difference between the Aid flow (current US$) of Barbados in 1998 and the Aid flow (current US$) of Sao Tome and Principe in 2000?
Ensure brevity in your answer.  -9.00e+04. What is the difference between the Aid flow (current US$) in Bulgaria in 1998 and the Aid flow (current US$) in Sao Tome and Principe in 2000?
Make the answer very short. 2.91e+07. What is the difference between the Aid flow (current US$) of World in 1998 and the Aid flow (current US$) of Barbados in 2001?
Your response must be concise. 3.73e+09. What is the difference between the Aid flow (current US$) of World in 1998 and the Aid flow (current US$) of Bulgaria in 2001?
Give a very brief answer. 3.69e+09. What is the difference between the Aid flow (current US$) in World in 1998 and the Aid flow (current US$) in Sao Tome and Principe in 2001?
Provide a succinct answer. 3.73e+09. What is the difference between the Aid flow (current US$) in Barbados in 1998 and the Aid flow (current US$) in Bulgaria in 2001?
Keep it short and to the point. -3.70e+07. What is the difference between the Aid flow (current US$) in Bulgaria in 1998 and the Aid flow (current US$) in Sao Tome and Principe in 2001?
Provide a succinct answer. 2.92e+07. What is the difference between the Aid flow (current US$) in World in 1999 and the Aid flow (current US$) in Barbados in 2000?
Provide a short and direct response. 3.52e+09. What is the difference between the Aid flow (current US$) in World in 1999 and the Aid flow (current US$) in Bulgaria in 2000?
Offer a terse response. 3.49e+09. What is the difference between the Aid flow (current US$) of World in 1999 and the Aid flow (current US$) of Sao Tome and Principe in 2000?
Your answer should be compact. 3.52e+09. What is the difference between the Aid flow (current US$) in Barbados in 1999 and the Aid flow (current US$) in Bulgaria in 2000?
Provide a short and direct response. -2.90e+07. What is the difference between the Aid flow (current US$) of Bulgaria in 1999 and the Aid flow (current US$) of Sao Tome and Principe in 2000?
Keep it short and to the point. 2.94e+07. What is the difference between the Aid flow (current US$) in World in 1999 and the Aid flow (current US$) in Barbados in 2001?
Make the answer very short. 3.52e+09. What is the difference between the Aid flow (current US$) in World in 1999 and the Aid flow (current US$) in Bulgaria in 2001?
Your answer should be compact. 3.48e+09. What is the difference between the Aid flow (current US$) of World in 1999 and the Aid flow (current US$) of Sao Tome and Principe in 2001?
Your answer should be very brief. 3.52e+09. What is the difference between the Aid flow (current US$) in Barbados in 1999 and the Aid flow (current US$) in Bulgaria in 2001?
Provide a succinct answer. -3.70e+07. What is the difference between the Aid flow (current US$) in Bulgaria in 1999 and the Aid flow (current US$) in Sao Tome and Principe in 2001?
Make the answer very short. 2.95e+07. What is the difference between the Aid flow (current US$) of World in 2000 and the Aid flow (current US$) of Barbados in 2001?
Keep it short and to the point. 2.91e+09. What is the difference between the Aid flow (current US$) in World in 2000 and the Aid flow (current US$) in Bulgaria in 2001?
Your answer should be compact. 2.87e+09. What is the difference between the Aid flow (current US$) in World in 2000 and the Aid flow (current US$) in Sao Tome and Principe in 2001?
Provide a short and direct response. 2.91e+09. What is the difference between the Aid flow (current US$) of Barbados in 2000 and the Aid flow (current US$) of Bulgaria in 2001?
Offer a terse response. -3.70e+07. What is the difference between the Aid flow (current US$) of Bulgaria in 2000 and the Aid flow (current US$) of Sao Tome and Principe in 2001?
Ensure brevity in your answer.  2.90e+07. What is the average Aid flow (current US$) of World per year?
Offer a terse response. 4.71e+09. What is the average Aid flow (current US$) of Barbados per year?
Offer a terse response. 5.75e+04. What is the average Aid flow (current US$) in Bulgaria per year?
Offer a very short reply. 2.59e+07. What is the average Aid flow (current US$) of Sao Tome and Principe per year?
Offer a terse response. 4.38e+05. In the year 1994, what is the difference between the Aid flow (current US$) of World and Aid flow (current US$) of Barbados?
Offer a very short reply. 6.11e+09. In the year 1994, what is the difference between the Aid flow (current US$) of World and Aid flow (current US$) of Bulgaria?
Your response must be concise. 6.09e+09. In the year 1994, what is the difference between the Aid flow (current US$) in World and Aid flow (current US$) in Sao Tome and Principe?
Offer a very short reply. 6.11e+09. In the year 1994, what is the difference between the Aid flow (current US$) of Barbados and Aid flow (current US$) of Bulgaria?
Your answer should be compact. -2.02e+07. In the year 1994, what is the difference between the Aid flow (current US$) in Barbados and Aid flow (current US$) in Sao Tome and Principe?
Ensure brevity in your answer.  -8.90e+05. In the year 1994, what is the difference between the Aid flow (current US$) of Bulgaria and Aid flow (current US$) of Sao Tome and Principe?
Keep it short and to the point. 1.93e+07. In the year 1995, what is the difference between the Aid flow (current US$) of World and Aid flow (current US$) of Barbados?
Your answer should be very brief. 8.92e+09. In the year 1995, what is the difference between the Aid flow (current US$) in World and Aid flow (current US$) in Bulgaria?
Your answer should be compact. 8.91e+09. In the year 1995, what is the difference between the Aid flow (current US$) of World and Aid flow (current US$) of Sao Tome and Principe?
Offer a very short reply. 8.92e+09. In the year 1995, what is the difference between the Aid flow (current US$) in Barbados and Aid flow (current US$) in Bulgaria?
Offer a very short reply. -1.46e+07. In the year 1995, what is the difference between the Aid flow (current US$) in Barbados and Aid flow (current US$) in Sao Tome and Principe?
Your answer should be very brief. -8.00e+05. In the year 1995, what is the difference between the Aid flow (current US$) of Bulgaria and Aid flow (current US$) of Sao Tome and Principe?
Ensure brevity in your answer.  1.38e+07. In the year 1996, what is the difference between the Aid flow (current US$) in World and Aid flow (current US$) in Barbados?
Give a very brief answer. 5.42e+09. In the year 1996, what is the difference between the Aid flow (current US$) in World and Aid flow (current US$) in Bulgaria?
Make the answer very short. 5.40e+09. In the year 1996, what is the difference between the Aid flow (current US$) in World and Aid flow (current US$) in Sao Tome and Principe?
Offer a very short reply. 5.42e+09. In the year 1996, what is the difference between the Aid flow (current US$) of Barbados and Aid flow (current US$) of Bulgaria?
Keep it short and to the point. -2.49e+07. In the year 1996, what is the difference between the Aid flow (current US$) of Barbados and Aid flow (current US$) of Sao Tome and Principe?
Offer a terse response. -5.50e+05. In the year 1996, what is the difference between the Aid flow (current US$) of Bulgaria and Aid flow (current US$) of Sao Tome and Principe?
Give a very brief answer. 2.44e+07. In the year 1997, what is the difference between the Aid flow (current US$) in World and Aid flow (current US$) in Barbados?
Provide a short and direct response. 3.94e+09. In the year 1997, what is the difference between the Aid flow (current US$) of World and Aid flow (current US$) of Bulgaria?
Your response must be concise. 3.92e+09. In the year 1997, what is the difference between the Aid flow (current US$) of World and Aid flow (current US$) of Sao Tome and Principe?
Your response must be concise. 3.94e+09. In the year 1997, what is the difference between the Aid flow (current US$) in Barbados and Aid flow (current US$) in Bulgaria?
Keep it short and to the point. -2.27e+07. In the year 1997, what is the difference between the Aid flow (current US$) of Bulgaria and Aid flow (current US$) of Sao Tome and Principe?
Provide a succinct answer. 2.24e+07. In the year 1998, what is the difference between the Aid flow (current US$) of World and Aid flow (current US$) of Barbados?
Ensure brevity in your answer.  3.73e+09. In the year 1998, what is the difference between the Aid flow (current US$) in World and Aid flow (current US$) in Bulgaria?
Your answer should be compact. 3.70e+09. In the year 1998, what is the difference between the Aid flow (current US$) of World and Aid flow (current US$) of Sao Tome and Principe?
Your answer should be very brief. 3.73e+09. In the year 1998, what is the difference between the Aid flow (current US$) of Barbados and Aid flow (current US$) of Bulgaria?
Provide a short and direct response. -2.92e+07. In the year 1998, what is the difference between the Aid flow (current US$) of Barbados and Aid flow (current US$) of Sao Tome and Principe?
Offer a very short reply. -3.60e+05. In the year 1998, what is the difference between the Aid flow (current US$) in Bulgaria and Aid flow (current US$) in Sao Tome and Principe?
Ensure brevity in your answer.  2.88e+07. In the year 1999, what is the difference between the Aid flow (current US$) in World and Aid flow (current US$) in Barbados?
Offer a very short reply. 3.52e+09. In the year 1999, what is the difference between the Aid flow (current US$) of World and Aid flow (current US$) of Bulgaria?
Provide a succinct answer. 3.49e+09. In the year 1999, what is the difference between the Aid flow (current US$) in World and Aid flow (current US$) in Sao Tome and Principe?
Your answer should be very brief. 3.52e+09. In the year 1999, what is the difference between the Aid flow (current US$) in Barbados and Aid flow (current US$) in Bulgaria?
Provide a succinct answer. -2.94e+07. In the year 1999, what is the difference between the Aid flow (current US$) in Bulgaria and Aid flow (current US$) in Sao Tome and Principe?
Your answer should be very brief. 2.93e+07. In the year 2000, what is the difference between the Aid flow (current US$) in World and Aid flow (current US$) in Barbados?
Your answer should be very brief. 2.91e+09. In the year 2000, what is the difference between the Aid flow (current US$) of World and Aid flow (current US$) of Bulgaria?
Offer a very short reply. 2.88e+09. In the year 2000, what is the difference between the Aid flow (current US$) in World and Aid flow (current US$) in Sao Tome and Principe?
Provide a short and direct response. 2.91e+09. In the year 2000, what is the difference between the Aid flow (current US$) of Barbados and Aid flow (current US$) of Bulgaria?
Keep it short and to the point. -2.90e+07. In the year 2000, what is the difference between the Aid flow (current US$) of Barbados and Aid flow (current US$) of Sao Tome and Principe?
Your answer should be very brief. -1.20e+05. In the year 2000, what is the difference between the Aid flow (current US$) of Bulgaria and Aid flow (current US$) of Sao Tome and Principe?
Offer a terse response. 2.89e+07. In the year 2001, what is the difference between the Aid flow (current US$) in World and Aid flow (current US$) in Barbados?
Keep it short and to the point. 3.10e+09. In the year 2001, what is the difference between the Aid flow (current US$) in World and Aid flow (current US$) in Bulgaria?
Provide a short and direct response. 3.06e+09. In the year 2001, what is the difference between the Aid flow (current US$) of World and Aid flow (current US$) of Sao Tome and Principe?
Provide a succinct answer. 3.10e+09. In the year 2001, what is the difference between the Aid flow (current US$) in Barbados and Aid flow (current US$) in Bulgaria?
Provide a succinct answer. -3.70e+07. In the year 2001, what is the difference between the Aid flow (current US$) in Barbados and Aid flow (current US$) in Sao Tome and Principe?
Make the answer very short. 5.00e+04. In the year 2001, what is the difference between the Aid flow (current US$) of Bulgaria and Aid flow (current US$) of Sao Tome and Principe?
Ensure brevity in your answer.  3.70e+07. What is the ratio of the Aid flow (current US$) in World in 1994 to that in 1995?
Your answer should be compact. 0.68. What is the ratio of the Aid flow (current US$) of Barbados in 1994 to that in 1995?
Your answer should be very brief. 1. What is the ratio of the Aid flow (current US$) of Bulgaria in 1994 to that in 1995?
Ensure brevity in your answer.  1.38. What is the ratio of the Aid flow (current US$) in Sao Tome and Principe in 1994 to that in 1995?
Your answer should be compact. 1.11. What is the ratio of the Aid flow (current US$) in World in 1994 to that in 1996?
Provide a succinct answer. 1.13. What is the ratio of the Aid flow (current US$) of Barbados in 1994 to that in 1996?
Your answer should be compact. 1. What is the ratio of the Aid flow (current US$) of Bulgaria in 1994 to that in 1996?
Provide a succinct answer. 0.81. What is the ratio of the Aid flow (current US$) of Sao Tome and Principe in 1994 to that in 1996?
Offer a very short reply. 1.59. What is the ratio of the Aid flow (current US$) in World in 1994 to that in 1997?
Your answer should be very brief. 1.55. What is the ratio of the Aid flow (current US$) of Bulgaria in 1994 to that in 1997?
Make the answer very short. 0.89. What is the ratio of the Aid flow (current US$) of Sao Tome and Principe in 1994 to that in 1997?
Provide a succinct answer. 3.07. What is the ratio of the Aid flow (current US$) in World in 1994 to that in 1998?
Make the answer very short. 1.64. What is the ratio of the Aid flow (current US$) in Barbados in 1994 to that in 1998?
Keep it short and to the point. 0.43. What is the ratio of the Aid flow (current US$) of Bulgaria in 1994 to that in 1998?
Your response must be concise. 0.69. What is the ratio of the Aid flow (current US$) in Sao Tome and Principe in 1994 to that in 1998?
Give a very brief answer. 2.14. What is the ratio of the Aid flow (current US$) in World in 1994 to that in 1999?
Offer a terse response. 1.74. What is the ratio of the Aid flow (current US$) in Bulgaria in 1994 to that in 1999?
Your response must be concise. 0.68. What is the ratio of the Aid flow (current US$) in Sao Tome and Principe in 1994 to that in 1999?
Your response must be concise. 3.83. What is the ratio of the Aid flow (current US$) in World in 1994 to that in 2000?
Make the answer very short. 2.1. What is the ratio of the Aid flow (current US$) in Barbados in 1994 to that in 2000?
Give a very brief answer. 0.75. What is the ratio of the Aid flow (current US$) in Bulgaria in 1994 to that in 2000?
Offer a very short reply. 0.69. What is the ratio of the Aid flow (current US$) of Sao Tome and Principe in 1994 to that in 2000?
Provide a short and direct response. 5.75. What is the ratio of the Aid flow (current US$) of World in 1994 to that in 2001?
Provide a succinct answer. 1.97. What is the ratio of the Aid flow (current US$) of Bulgaria in 1994 to that in 2001?
Offer a very short reply. 0.54. What is the ratio of the Aid flow (current US$) of World in 1995 to that in 1996?
Your answer should be compact. 1.65. What is the ratio of the Aid flow (current US$) of Barbados in 1995 to that in 1996?
Ensure brevity in your answer.  1. What is the ratio of the Aid flow (current US$) of Bulgaria in 1995 to that in 1996?
Your answer should be compact. 0.59. What is the ratio of the Aid flow (current US$) of Sao Tome and Principe in 1995 to that in 1996?
Offer a terse response. 1.43. What is the ratio of the Aid flow (current US$) in World in 1995 to that in 1997?
Your response must be concise. 2.26. What is the ratio of the Aid flow (current US$) of Bulgaria in 1995 to that in 1997?
Your answer should be very brief. 0.65. What is the ratio of the Aid flow (current US$) of Sao Tome and Principe in 1995 to that in 1997?
Offer a very short reply. 2.77. What is the ratio of the Aid flow (current US$) of World in 1995 to that in 1998?
Your answer should be compact. 2.39. What is the ratio of the Aid flow (current US$) in Barbados in 1995 to that in 1998?
Make the answer very short. 0.43. What is the ratio of the Aid flow (current US$) in Bulgaria in 1995 to that in 1998?
Your answer should be very brief. 0.5. What is the ratio of the Aid flow (current US$) in Sao Tome and Principe in 1995 to that in 1998?
Offer a very short reply. 1.93. What is the ratio of the Aid flow (current US$) of World in 1995 to that in 1999?
Keep it short and to the point. 2.53. What is the ratio of the Aid flow (current US$) of Bulgaria in 1995 to that in 1999?
Give a very brief answer. 0.5. What is the ratio of the Aid flow (current US$) of Sao Tome and Principe in 1995 to that in 1999?
Offer a terse response. 3.46. What is the ratio of the Aid flow (current US$) in World in 1995 to that in 2000?
Offer a very short reply. 3.07. What is the ratio of the Aid flow (current US$) of Barbados in 1995 to that in 2000?
Keep it short and to the point. 0.75. What is the ratio of the Aid flow (current US$) of Bulgaria in 1995 to that in 2000?
Your answer should be very brief. 0.5. What is the ratio of the Aid flow (current US$) of Sao Tome and Principe in 1995 to that in 2000?
Keep it short and to the point. 5.19. What is the ratio of the Aid flow (current US$) of World in 1995 to that in 2001?
Offer a terse response. 2.88. What is the ratio of the Aid flow (current US$) in Bulgaria in 1995 to that in 2001?
Offer a very short reply. 0.4. What is the ratio of the Aid flow (current US$) of Sao Tome and Principe in 1995 to that in 2001?
Your response must be concise. 20.75. What is the ratio of the Aid flow (current US$) of World in 1996 to that in 1997?
Make the answer very short. 1.38. What is the ratio of the Aid flow (current US$) of Bulgaria in 1996 to that in 1997?
Your answer should be compact. 1.1. What is the ratio of the Aid flow (current US$) of Sao Tome and Principe in 1996 to that in 1997?
Your answer should be very brief. 1.93. What is the ratio of the Aid flow (current US$) in World in 1996 to that in 1998?
Provide a short and direct response. 1.45. What is the ratio of the Aid flow (current US$) in Barbados in 1996 to that in 1998?
Give a very brief answer. 0.43. What is the ratio of the Aid flow (current US$) of Bulgaria in 1996 to that in 1998?
Your response must be concise. 0.85. What is the ratio of the Aid flow (current US$) in Sao Tome and Principe in 1996 to that in 1998?
Provide a succinct answer. 1.35. What is the ratio of the Aid flow (current US$) in World in 1996 to that in 1999?
Give a very brief answer. 1.54. What is the ratio of the Aid flow (current US$) of Barbados in 1996 to that in 1999?
Your answer should be very brief. 0.25. What is the ratio of the Aid flow (current US$) in Bulgaria in 1996 to that in 1999?
Offer a very short reply. 0.84. What is the ratio of the Aid flow (current US$) in Sao Tome and Principe in 1996 to that in 1999?
Keep it short and to the point. 2.42. What is the ratio of the Aid flow (current US$) of World in 1996 to that in 2000?
Your answer should be very brief. 1.86. What is the ratio of the Aid flow (current US$) in Bulgaria in 1996 to that in 2000?
Offer a terse response. 0.86. What is the ratio of the Aid flow (current US$) of Sao Tome and Principe in 1996 to that in 2000?
Provide a short and direct response. 3.62. What is the ratio of the Aid flow (current US$) in World in 1996 to that in 2001?
Give a very brief answer. 1.75. What is the ratio of the Aid flow (current US$) in Bulgaria in 1996 to that in 2001?
Ensure brevity in your answer.  0.67. What is the ratio of the Aid flow (current US$) of World in 1997 to that in 1998?
Ensure brevity in your answer.  1.06. What is the ratio of the Aid flow (current US$) in Bulgaria in 1997 to that in 1998?
Make the answer very short. 0.78. What is the ratio of the Aid flow (current US$) of Sao Tome and Principe in 1997 to that in 1998?
Make the answer very short. 0.7. What is the ratio of the Aid flow (current US$) in World in 1997 to that in 1999?
Your answer should be very brief. 1.12. What is the ratio of the Aid flow (current US$) in Barbados in 1997 to that in 1999?
Offer a terse response. 0.42. What is the ratio of the Aid flow (current US$) in Bulgaria in 1997 to that in 1999?
Give a very brief answer. 0.77. What is the ratio of the Aid flow (current US$) of World in 1997 to that in 2000?
Offer a very short reply. 1.35. What is the ratio of the Aid flow (current US$) in Bulgaria in 1997 to that in 2000?
Provide a short and direct response. 0.78. What is the ratio of the Aid flow (current US$) of Sao Tome and Principe in 1997 to that in 2000?
Ensure brevity in your answer.  1.88. What is the ratio of the Aid flow (current US$) in World in 1997 to that in 2001?
Offer a very short reply. 1.27. What is the ratio of the Aid flow (current US$) of Barbados in 1997 to that in 2001?
Offer a terse response. 0.56. What is the ratio of the Aid flow (current US$) in Bulgaria in 1997 to that in 2001?
Keep it short and to the point. 0.61. What is the ratio of the Aid flow (current US$) in Sao Tome and Principe in 1997 to that in 2001?
Your answer should be very brief. 7.5. What is the ratio of the Aid flow (current US$) of World in 1998 to that in 1999?
Provide a succinct answer. 1.06. What is the ratio of the Aid flow (current US$) of Barbados in 1998 to that in 1999?
Your answer should be compact. 0.58. What is the ratio of the Aid flow (current US$) of Bulgaria in 1998 to that in 1999?
Your response must be concise. 0.99. What is the ratio of the Aid flow (current US$) in Sao Tome and Principe in 1998 to that in 1999?
Offer a terse response. 1.79. What is the ratio of the Aid flow (current US$) in World in 1998 to that in 2000?
Give a very brief answer. 1.28. What is the ratio of the Aid flow (current US$) in Sao Tome and Principe in 1998 to that in 2000?
Your answer should be compact. 2.69. What is the ratio of the Aid flow (current US$) of World in 1998 to that in 2001?
Offer a terse response. 1.2. What is the ratio of the Aid flow (current US$) of Bulgaria in 1998 to that in 2001?
Give a very brief answer. 0.79. What is the ratio of the Aid flow (current US$) of Sao Tome and Principe in 1998 to that in 2001?
Give a very brief answer. 10.75. What is the ratio of the Aid flow (current US$) in World in 1999 to that in 2000?
Your response must be concise. 1.21. What is the ratio of the Aid flow (current US$) in Barbados in 1999 to that in 2000?
Make the answer very short. 3. What is the ratio of the Aid flow (current US$) of Bulgaria in 1999 to that in 2000?
Provide a succinct answer. 1.02. What is the ratio of the Aid flow (current US$) in Sao Tome and Principe in 1999 to that in 2000?
Offer a very short reply. 1.5. What is the ratio of the Aid flow (current US$) of World in 1999 to that in 2001?
Your answer should be compact. 1.14. What is the ratio of the Aid flow (current US$) in Bulgaria in 1999 to that in 2001?
Give a very brief answer. 0.8. What is the ratio of the Aid flow (current US$) in Sao Tome and Principe in 1999 to that in 2001?
Provide a succinct answer. 6. What is the ratio of the Aid flow (current US$) in World in 2000 to that in 2001?
Give a very brief answer. 0.94. What is the ratio of the Aid flow (current US$) of Barbados in 2000 to that in 2001?
Give a very brief answer. 0.44. What is the ratio of the Aid flow (current US$) in Bulgaria in 2000 to that in 2001?
Provide a succinct answer. 0.78. What is the difference between the highest and the second highest Aid flow (current US$) in World?
Give a very brief answer. 2.81e+09. What is the difference between the highest and the second highest Aid flow (current US$) of Bulgaria?
Your response must be concise. 7.53e+06. What is the difference between the highest and the lowest Aid flow (current US$) in World?
Your response must be concise. 6.01e+09. What is the difference between the highest and the lowest Aid flow (current US$) of Bulgaria?
Ensure brevity in your answer.  2.24e+07. What is the difference between the highest and the lowest Aid flow (current US$) in Sao Tome and Principe?
Keep it short and to the point. 8.80e+05. 